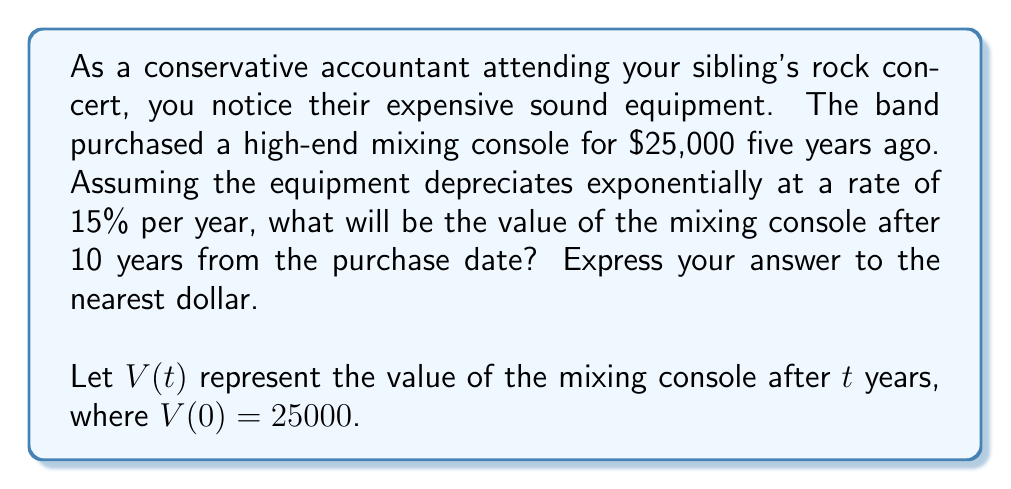Solve this math problem. To solve this problem, we'll use the exponential decay function:

$$V(t) = V_0 \cdot e^{-rt}$$

Where:
$V_0$ is the initial value
$r$ is the decay rate
$t$ is the time in years

1. Given information:
   $V_0 = 25000$
   $r = 0.15$ (15% annual depreciation rate)
   $t = 10$ years

2. Plug the values into the exponential decay function:

   $$V(10) = 25000 \cdot e^{-0.15 \cdot 10}$$

3. Simplify the exponent:
   
   $$V(10) = 25000 \cdot e^{-1.5}$$

4. Use a calculator to evaluate $e^{-1.5}$:
   
   $$V(10) = 25000 \cdot 0.22313016014842982$$

5. Multiply:
   
   $$V(10) = 5578.25400371074955$$

6. Round to the nearest dollar:
   
   $$V(10) \approx 5578$$

Therefore, after 10 years, the mixing console will be worth approximately $5,578.
Answer: $5,578 